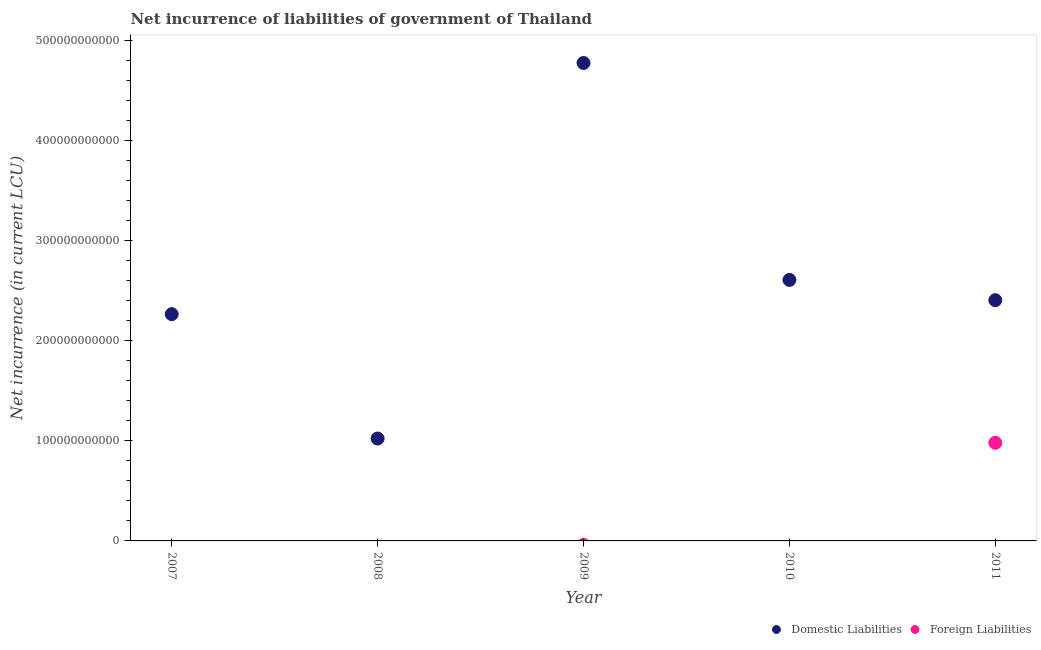How many different coloured dotlines are there?
Your answer should be very brief. 2. What is the net incurrence of domestic liabilities in 2011?
Ensure brevity in your answer.  2.41e+11. Across all years, what is the maximum net incurrence of domestic liabilities?
Give a very brief answer. 4.78e+11. Across all years, what is the minimum net incurrence of domestic liabilities?
Offer a terse response. 1.02e+11. What is the total net incurrence of foreign liabilities in the graph?
Offer a very short reply. 9.81e+1. What is the difference between the net incurrence of domestic liabilities in 2010 and that in 2011?
Provide a succinct answer. 2.03e+1. What is the difference between the net incurrence of foreign liabilities in 2010 and the net incurrence of domestic liabilities in 2009?
Offer a very short reply. -4.78e+11. What is the average net incurrence of foreign liabilities per year?
Your answer should be very brief. 1.96e+1. In the year 2011, what is the difference between the net incurrence of foreign liabilities and net incurrence of domestic liabilities?
Keep it short and to the point. -1.43e+11. What is the ratio of the net incurrence of domestic liabilities in 2009 to that in 2010?
Your answer should be very brief. 1.83. What is the difference between the highest and the second highest net incurrence of domestic liabilities?
Provide a succinct answer. 2.17e+11. What is the difference between the highest and the lowest net incurrence of foreign liabilities?
Make the answer very short. 9.81e+1. In how many years, is the net incurrence of foreign liabilities greater than the average net incurrence of foreign liabilities taken over all years?
Your answer should be very brief. 1. Does the net incurrence of domestic liabilities monotonically increase over the years?
Your answer should be compact. No. Is the net incurrence of domestic liabilities strictly less than the net incurrence of foreign liabilities over the years?
Ensure brevity in your answer.  No. How many dotlines are there?
Your answer should be very brief. 2. How many years are there in the graph?
Your answer should be compact. 5. What is the difference between two consecutive major ticks on the Y-axis?
Your response must be concise. 1.00e+11. Does the graph contain any zero values?
Keep it short and to the point. Yes. Does the graph contain grids?
Provide a short and direct response. No. Where does the legend appear in the graph?
Provide a short and direct response. Bottom right. How many legend labels are there?
Make the answer very short. 2. What is the title of the graph?
Keep it short and to the point. Net incurrence of liabilities of government of Thailand. What is the label or title of the X-axis?
Give a very brief answer. Year. What is the label or title of the Y-axis?
Your answer should be very brief. Net incurrence (in current LCU). What is the Net incurrence (in current LCU) in Domestic Liabilities in 2007?
Provide a succinct answer. 2.27e+11. What is the Net incurrence (in current LCU) in Foreign Liabilities in 2007?
Offer a terse response. 0. What is the Net incurrence (in current LCU) in Domestic Liabilities in 2008?
Provide a short and direct response. 1.02e+11. What is the Net incurrence (in current LCU) in Domestic Liabilities in 2009?
Give a very brief answer. 4.78e+11. What is the Net incurrence (in current LCU) in Domestic Liabilities in 2010?
Give a very brief answer. 2.61e+11. What is the Net incurrence (in current LCU) of Domestic Liabilities in 2011?
Your answer should be very brief. 2.41e+11. What is the Net incurrence (in current LCU) in Foreign Liabilities in 2011?
Your answer should be very brief. 9.81e+1. Across all years, what is the maximum Net incurrence (in current LCU) in Domestic Liabilities?
Ensure brevity in your answer.  4.78e+11. Across all years, what is the maximum Net incurrence (in current LCU) of Foreign Liabilities?
Offer a very short reply. 9.81e+1. Across all years, what is the minimum Net incurrence (in current LCU) in Domestic Liabilities?
Provide a short and direct response. 1.02e+11. What is the total Net incurrence (in current LCU) of Domestic Liabilities in the graph?
Provide a succinct answer. 1.31e+12. What is the total Net incurrence (in current LCU) in Foreign Liabilities in the graph?
Keep it short and to the point. 9.81e+1. What is the difference between the Net incurrence (in current LCU) of Domestic Liabilities in 2007 and that in 2008?
Provide a succinct answer. 1.24e+11. What is the difference between the Net incurrence (in current LCU) in Domestic Liabilities in 2007 and that in 2009?
Give a very brief answer. -2.51e+11. What is the difference between the Net incurrence (in current LCU) of Domestic Liabilities in 2007 and that in 2010?
Provide a succinct answer. -3.42e+1. What is the difference between the Net incurrence (in current LCU) in Domestic Liabilities in 2007 and that in 2011?
Keep it short and to the point. -1.40e+1. What is the difference between the Net incurrence (in current LCU) in Domestic Liabilities in 2008 and that in 2009?
Ensure brevity in your answer.  -3.75e+11. What is the difference between the Net incurrence (in current LCU) of Domestic Liabilities in 2008 and that in 2010?
Provide a short and direct response. -1.59e+11. What is the difference between the Net incurrence (in current LCU) in Domestic Liabilities in 2008 and that in 2011?
Offer a terse response. -1.38e+11. What is the difference between the Net incurrence (in current LCU) of Domestic Liabilities in 2009 and that in 2010?
Provide a short and direct response. 2.17e+11. What is the difference between the Net incurrence (in current LCU) in Domestic Liabilities in 2009 and that in 2011?
Make the answer very short. 2.37e+11. What is the difference between the Net incurrence (in current LCU) in Domestic Liabilities in 2010 and that in 2011?
Offer a very short reply. 2.03e+1. What is the difference between the Net incurrence (in current LCU) of Domestic Liabilities in 2007 and the Net incurrence (in current LCU) of Foreign Liabilities in 2011?
Offer a very short reply. 1.29e+11. What is the difference between the Net incurrence (in current LCU) in Domestic Liabilities in 2008 and the Net incurrence (in current LCU) in Foreign Liabilities in 2011?
Offer a terse response. 4.30e+09. What is the difference between the Net incurrence (in current LCU) in Domestic Liabilities in 2009 and the Net incurrence (in current LCU) in Foreign Liabilities in 2011?
Your answer should be compact. 3.80e+11. What is the difference between the Net incurrence (in current LCU) in Domestic Liabilities in 2010 and the Net incurrence (in current LCU) in Foreign Liabilities in 2011?
Your response must be concise. 1.63e+11. What is the average Net incurrence (in current LCU) of Domestic Liabilities per year?
Provide a short and direct response. 2.62e+11. What is the average Net incurrence (in current LCU) in Foreign Liabilities per year?
Keep it short and to the point. 1.96e+1. In the year 2011, what is the difference between the Net incurrence (in current LCU) of Domestic Liabilities and Net incurrence (in current LCU) of Foreign Liabilities?
Keep it short and to the point. 1.43e+11. What is the ratio of the Net incurrence (in current LCU) of Domestic Liabilities in 2007 to that in 2008?
Offer a terse response. 2.21. What is the ratio of the Net incurrence (in current LCU) in Domestic Liabilities in 2007 to that in 2009?
Your answer should be compact. 0.47. What is the ratio of the Net incurrence (in current LCU) in Domestic Liabilities in 2007 to that in 2010?
Your answer should be very brief. 0.87. What is the ratio of the Net incurrence (in current LCU) of Domestic Liabilities in 2007 to that in 2011?
Offer a very short reply. 0.94. What is the ratio of the Net incurrence (in current LCU) of Domestic Liabilities in 2008 to that in 2009?
Keep it short and to the point. 0.21. What is the ratio of the Net incurrence (in current LCU) of Domestic Liabilities in 2008 to that in 2010?
Make the answer very short. 0.39. What is the ratio of the Net incurrence (in current LCU) in Domestic Liabilities in 2008 to that in 2011?
Provide a short and direct response. 0.43. What is the ratio of the Net incurrence (in current LCU) of Domestic Liabilities in 2009 to that in 2010?
Offer a terse response. 1.83. What is the ratio of the Net incurrence (in current LCU) of Domestic Liabilities in 2009 to that in 2011?
Provide a short and direct response. 1.99. What is the ratio of the Net incurrence (in current LCU) of Domestic Liabilities in 2010 to that in 2011?
Keep it short and to the point. 1.08. What is the difference between the highest and the second highest Net incurrence (in current LCU) in Domestic Liabilities?
Your response must be concise. 2.17e+11. What is the difference between the highest and the lowest Net incurrence (in current LCU) of Domestic Liabilities?
Provide a succinct answer. 3.75e+11. What is the difference between the highest and the lowest Net incurrence (in current LCU) of Foreign Liabilities?
Your response must be concise. 9.81e+1. 